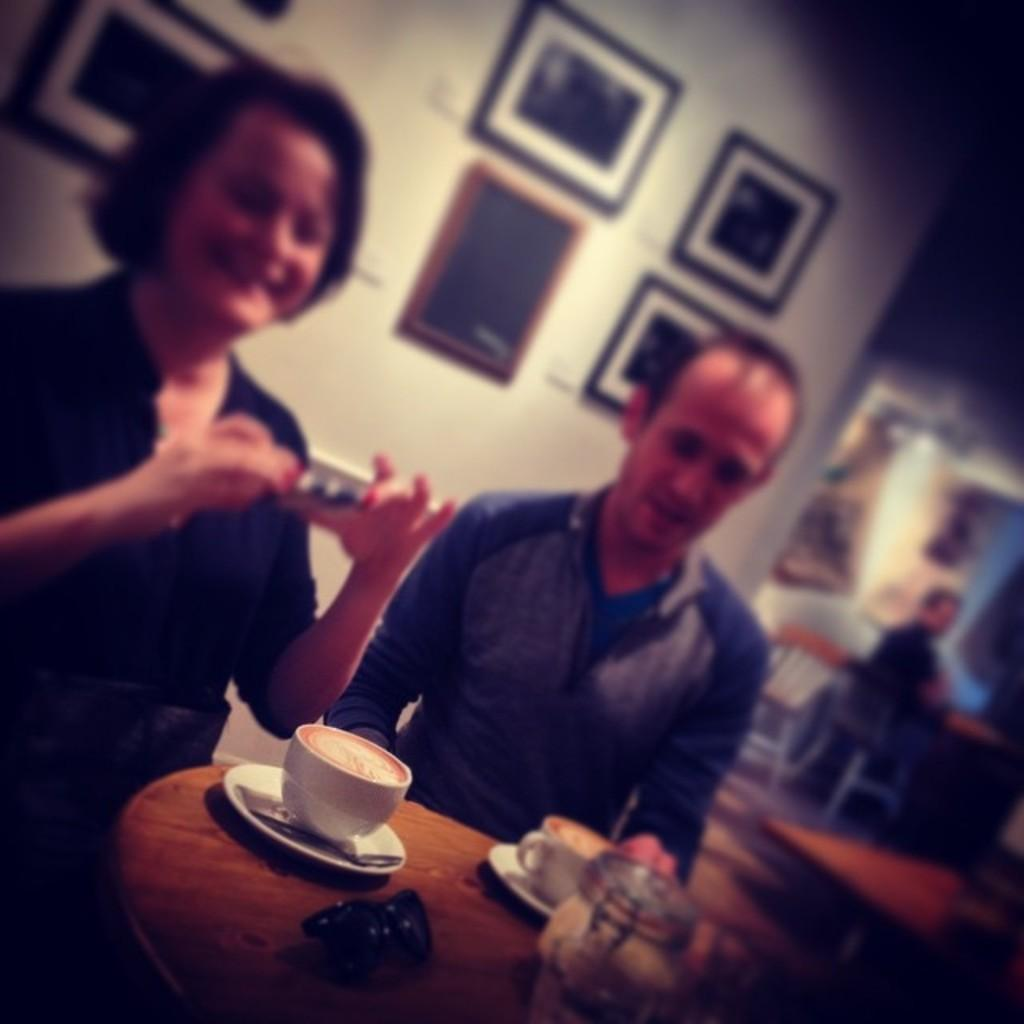Who is present in the image? There is a couple in the image. What are they doing in the image? The couple is sitting at a table. Where is the table located? The table is in a coffee shop. What is on the table in front of the couple? There is coffee in front of the couple. What type of jeans is the man wearing in the image? There is no information about the man's clothing in the image, so it cannot be determined if he is wearing jeans or any other type of clothing. 